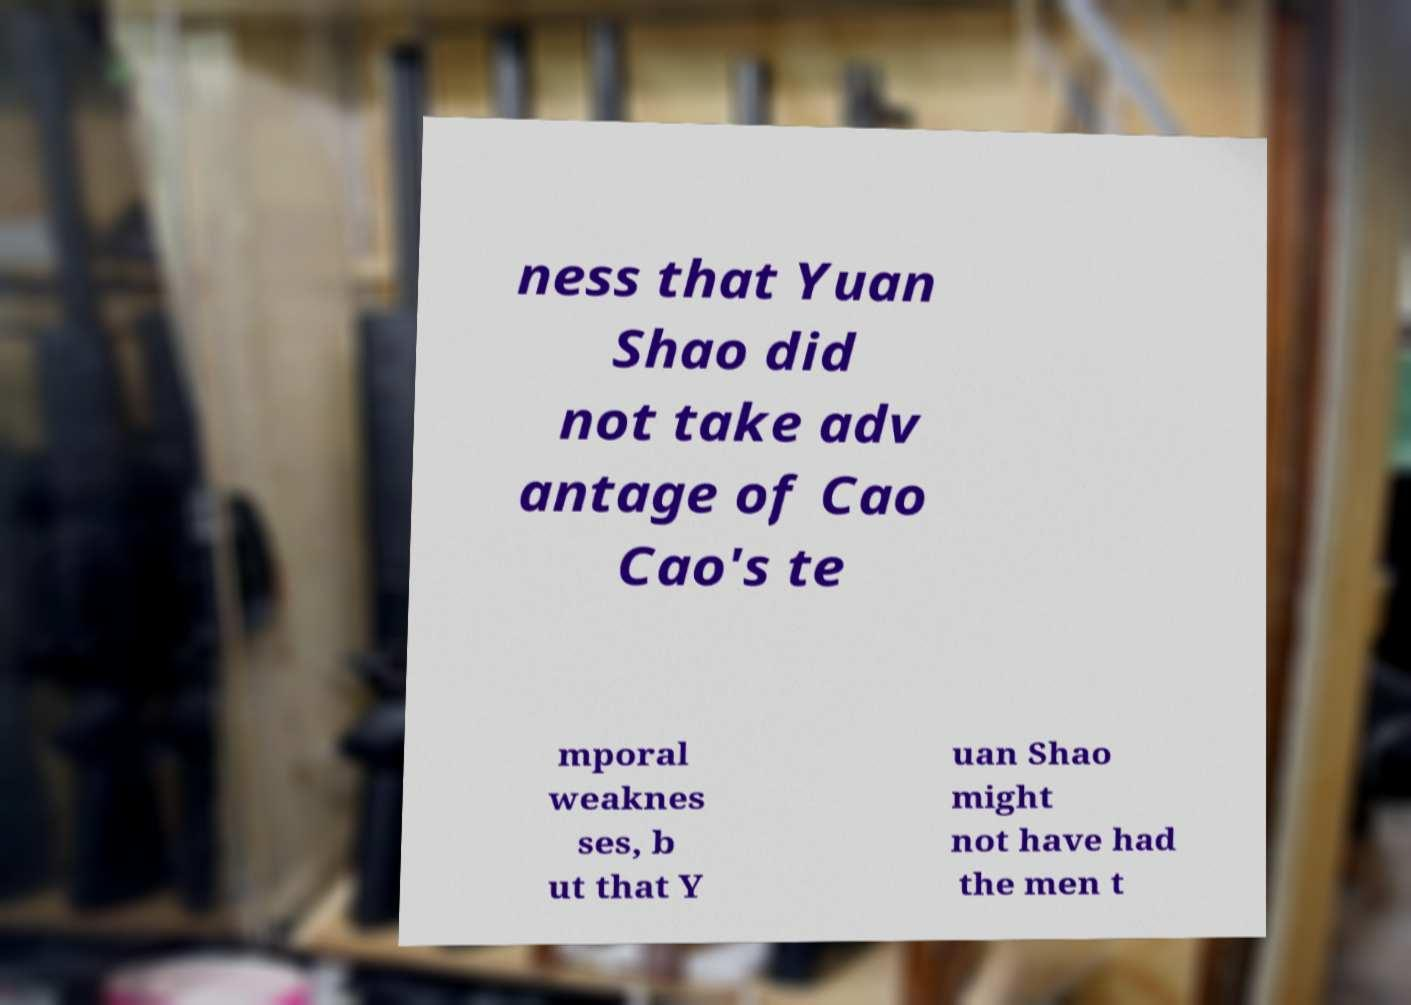Could you assist in decoding the text presented in this image and type it out clearly? ness that Yuan Shao did not take adv antage of Cao Cao's te mporal weaknes ses, b ut that Y uan Shao might not have had the men t 